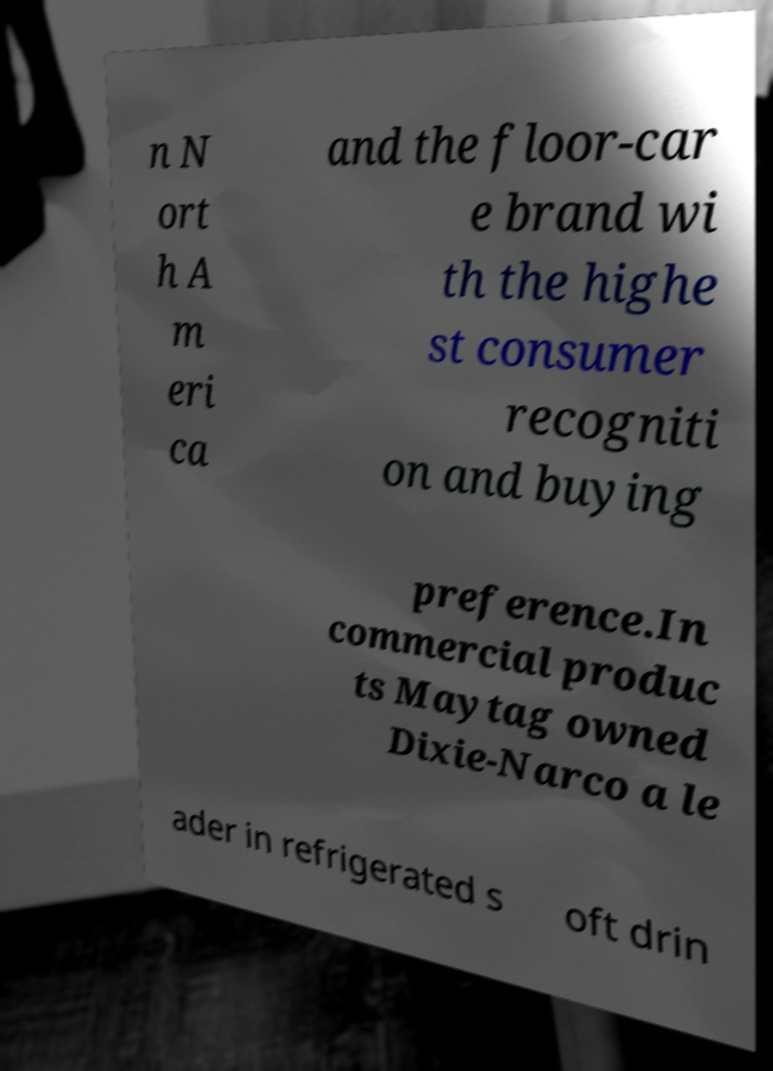Please read and relay the text visible in this image. What does it say? n N ort h A m eri ca and the floor-car e brand wi th the highe st consumer recogniti on and buying preference.In commercial produc ts Maytag owned Dixie-Narco a le ader in refrigerated s oft drin 